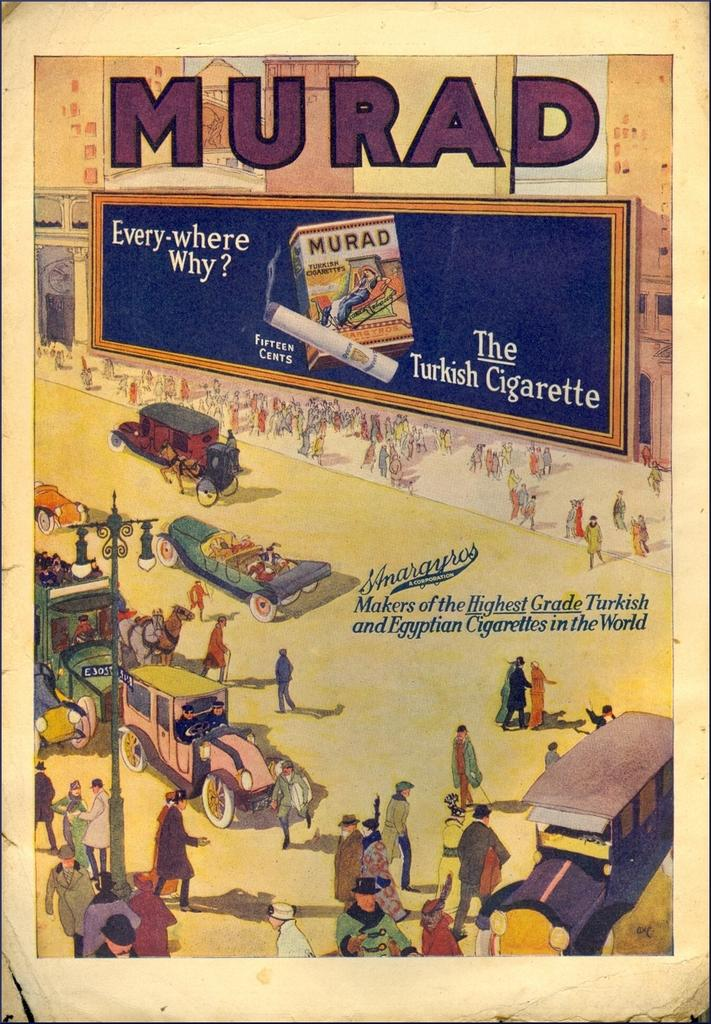<image>
Present a compact description of the photo's key features. Poster with people walking outdoors and says MURAD on top. 